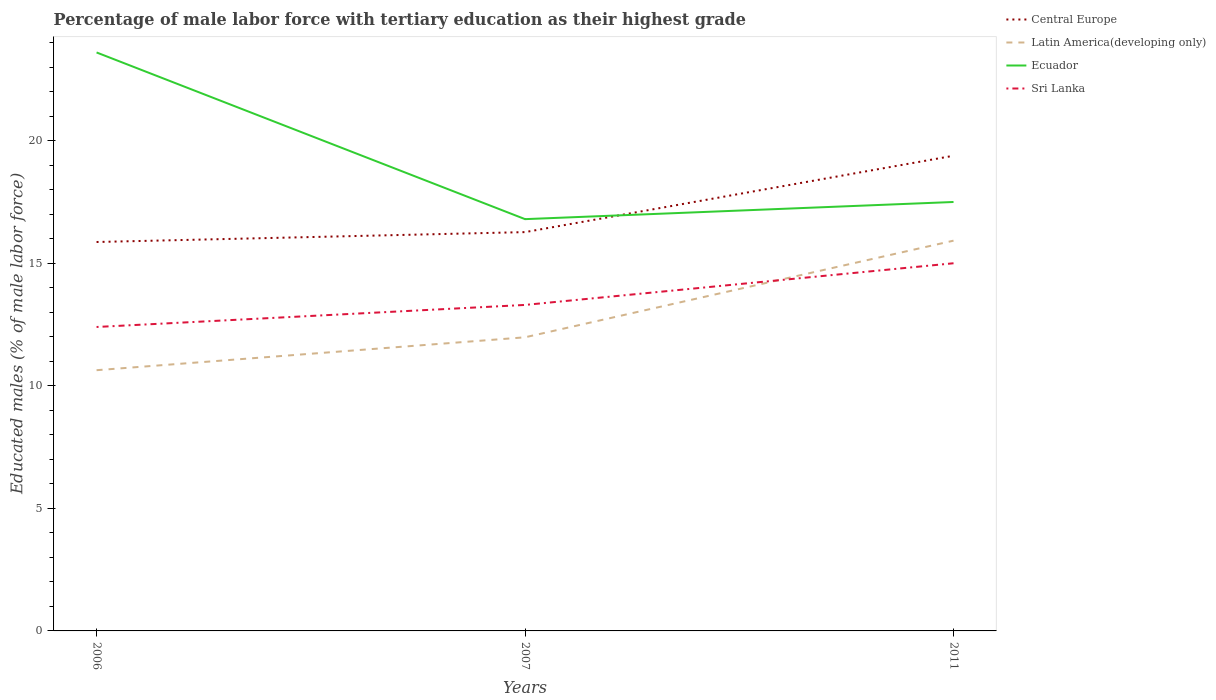Does the line corresponding to Ecuador intersect with the line corresponding to Central Europe?
Keep it short and to the point. Yes. Across all years, what is the maximum percentage of male labor force with tertiary education in Central Europe?
Give a very brief answer. 15.87. In which year was the percentage of male labor force with tertiary education in Latin America(developing only) maximum?
Provide a short and direct response. 2006. What is the total percentage of male labor force with tertiary education in Ecuador in the graph?
Offer a terse response. 6.8. What is the difference between the highest and the second highest percentage of male labor force with tertiary education in Sri Lanka?
Your answer should be compact. 2.6. Is the percentage of male labor force with tertiary education in Latin America(developing only) strictly greater than the percentage of male labor force with tertiary education in Central Europe over the years?
Make the answer very short. Yes. Does the graph contain grids?
Provide a short and direct response. No. Where does the legend appear in the graph?
Provide a short and direct response. Top right. How many legend labels are there?
Provide a short and direct response. 4. What is the title of the graph?
Keep it short and to the point. Percentage of male labor force with tertiary education as their highest grade. Does "Belarus" appear as one of the legend labels in the graph?
Your response must be concise. No. What is the label or title of the X-axis?
Keep it short and to the point. Years. What is the label or title of the Y-axis?
Offer a terse response. Educated males (% of male labor force). What is the Educated males (% of male labor force) of Central Europe in 2006?
Give a very brief answer. 15.87. What is the Educated males (% of male labor force) in Latin America(developing only) in 2006?
Your answer should be very brief. 10.64. What is the Educated males (% of male labor force) in Ecuador in 2006?
Your response must be concise. 23.6. What is the Educated males (% of male labor force) of Sri Lanka in 2006?
Provide a succinct answer. 12.4. What is the Educated males (% of male labor force) of Central Europe in 2007?
Your answer should be compact. 16.27. What is the Educated males (% of male labor force) in Latin America(developing only) in 2007?
Your response must be concise. 11.98. What is the Educated males (% of male labor force) of Ecuador in 2007?
Your answer should be very brief. 16.8. What is the Educated males (% of male labor force) in Sri Lanka in 2007?
Your answer should be compact. 13.3. What is the Educated males (% of male labor force) of Central Europe in 2011?
Your answer should be very brief. 19.39. What is the Educated males (% of male labor force) of Latin America(developing only) in 2011?
Provide a succinct answer. 15.92. Across all years, what is the maximum Educated males (% of male labor force) in Central Europe?
Make the answer very short. 19.39. Across all years, what is the maximum Educated males (% of male labor force) in Latin America(developing only)?
Make the answer very short. 15.92. Across all years, what is the maximum Educated males (% of male labor force) of Ecuador?
Ensure brevity in your answer.  23.6. Across all years, what is the minimum Educated males (% of male labor force) in Central Europe?
Provide a short and direct response. 15.87. Across all years, what is the minimum Educated males (% of male labor force) in Latin America(developing only)?
Your response must be concise. 10.64. Across all years, what is the minimum Educated males (% of male labor force) in Ecuador?
Your answer should be very brief. 16.8. Across all years, what is the minimum Educated males (% of male labor force) of Sri Lanka?
Provide a short and direct response. 12.4. What is the total Educated males (% of male labor force) of Central Europe in the graph?
Keep it short and to the point. 51.52. What is the total Educated males (% of male labor force) in Latin America(developing only) in the graph?
Provide a short and direct response. 38.54. What is the total Educated males (% of male labor force) of Ecuador in the graph?
Your response must be concise. 57.9. What is the total Educated males (% of male labor force) in Sri Lanka in the graph?
Your response must be concise. 40.7. What is the difference between the Educated males (% of male labor force) in Central Europe in 2006 and that in 2007?
Provide a succinct answer. -0.4. What is the difference between the Educated males (% of male labor force) of Latin America(developing only) in 2006 and that in 2007?
Give a very brief answer. -1.34. What is the difference between the Educated males (% of male labor force) in Sri Lanka in 2006 and that in 2007?
Give a very brief answer. -0.9. What is the difference between the Educated males (% of male labor force) in Central Europe in 2006 and that in 2011?
Offer a very short reply. -3.52. What is the difference between the Educated males (% of male labor force) of Latin America(developing only) in 2006 and that in 2011?
Ensure brevity in your answer.  -5.28. What is the difference between the Educated males (% of male labor force) in Central Europe in 2007 and that in 2011?
Your answer should be very brief. -3.12. What is the difference between the Educated males (% of male labor force) in Latin America(developing only) in 2007 and that in 2011?
Make the answer very short. -3.94. What is the difference between the Educated males (% of male labor force) of Ecuador in 2007 and that in 2011?
Ensure brevity in your answer.  -0.7. What is the difference between the Educated males (% of male labor force) of Sri Lanka in 2007 and that in 2011?
Provide a short and direct response. -1.7. What is the difference between the Educated males (% of male labor force) of Central Europe in 2006 and the Educated males (% of male labor force) of Latin America(developing only) in 2007?
Your answer should be compact. 3.89. What is the difference between the Educated males (% of male labor force) in Central Europe in 2006 and the Educated males (% of male labor force) in Ecuador in 2007?
Your answer should be very brief. -0.93. What is the difference between the Educated males (% of male labor force) of Central Europe in 2006 and the Educated males (% of male labor force) of Sri Lanka in 2007?
Provide a succinct answer. 2.57. What is the difference between the Educated males (% of male labor force) of Latin America(developing only) in 2006 and the Educated males (% of male labor force) of Ecuador in 2007?
Ensure brevity in your answer.  -6.16. What is the difference between the Educated males (% of male labor force) of Latin America(developing only) in 2006 and the Educated males (% of male labor force) of Sri Lanka in 2007?
Ensure brevity in your answer.  -2.66. What is the difference between the Educated males (% of male labor force) of Central Europe in 2006 and the Educated males (% of male labor force) of Latin America(developing only) in 2011?
Your answer should be compact. -0.05. What is the difference between the Educated males (% of male labor force) of Central Europe in 2006 and the Educated males (% of male labor force) of Ecuador in 2011?
Offer a terse response. -1.63. What is the difference between the Educated males (% of male labor force) in Central Europe in 2006 and the Educated males (% of male labor force) in Sri Lanka in 2011?
Your response must be concise. 0.87. What is the difference between the Educated males (% of male labor force) in Latin America(developing only) in 2006 and the Educated males (% of male labor force) in Ecuador in 2011?
Your answer should be compact. -6.86. What is the difference between the Educated males (% of male labor force) of Latin America(developing only) in 2006 and the Educated males (% of male labor force) of Sri Lanka in 2011?
Your answer should be very brief. -4.36. What is the difference between the Educated males (% of male labor force) of Central Europe in 2007 and the Educated males (% of male labor force) of Latin America(developing only) in 2011?
Offer a very short reply. 0.35. What is the difference between the Educated males (% of male labor force) in Central Europe in 2007 and the Educated males (% of male labor force) in Ecuador in 2011?
Offer a very short reply. -1.23. What is the difference between the Educated males (% of male labor force) of Central Europe in 2007 and the Educated males (% of male labor force) of Sri Lanka in 2011?
Ensure brevity in your answer.  1.27. What is the difference between the Educated males (% of male labor force) in Latin America(developing only) in 2007 and the Educated males (% of male labor force) in Ecuador in 2011?
Provide a short and direct response. -5.52. What is the difference between the Educated males (% of male labor force) in Latin America(developing only) in 2007 and the Educated males (% of male labor force) in Sri Lanka in 2011?
Your answer should be very brief. -3.02. What is the difference between the Educated males (% of male labor force) of Ecuador in 2007 and the Educated males (% of male labor force) of Sri Lanka in 2011?
Your answer should be very brief. 1.8. What is the average Educated males (% of male labor force) of Central Europe per year?
Your response must be concise. 17.17. What is the average Educated males (% of male labor force) in Latin America(developing only) per year?
Your answer should be very brief. 12.85. What is the average Educated males (% of male labor force) in Ecuador per year?
Provide a short and direct response. 19.3. What is the average Educated males (% of male labor force) in Sri Lanka per year?
Your answer should be compact. 13.57. In the year 2006, what is the difference between the Educated males (% of male labor force) in Central Europe and Educated males (% of male labor force) in Latin America(developing only)?
Your answer should be very brief. 5.23. In the year 2006, what is the difference between the Educated males (% of male labor force) of Central Europe and Educated males (% of male labor force) of Ecuador?
Your response must be concise. -7.73. In the year 2006, what is the difference between the Educated males (% of male labor force) of Central Europe and Educated males (% of male labor force) of Sri Lanka?
Keep it short and to the point. 3.47. In the year 2006, what is the difference between the Educated males (% of male labor force) in Latin America(developing only) and Educated males (% of male labor force) in Ecuador?
Your response must be concise. -12.96. In the year 2006, what is the difference between the Educated males (% of male labor force) of Latin America(developing only) and Educated males (% of male labor force) of Sri Lanka?
Provide a short and direct response. -1.76. In the year 2006, what is the difference between the Educated males (% of male labor force) in Ecuador and Educated males (% of male labor force) in Sri Lanka?
Your answer should be compact. 11.2. In the year 2007, what is the difference between the Educated males (% of male labor force) in Central Europe and Educated males (% of male labor force) in Latin America(developing only)?
Provide a short and direct response. 4.29. In the year 2007, what is the difference between the Educated males (% of male labor force) in Central Europe and Educated males (% of male labor force) in Ecuador?
Offer a terse response. -0.53. In the year 2007, what is the difference between the Educated males (% of male labor force) in Central Europe and Educated males (% of male labor force) in Sri Lanka?
Provide a short and direct response. 2.97. In the year 2007, what is the difference between the Educated males (% of male labor force) of Latin America(developing only) and Educated males (% of male labor force) of Ecuador?
Provide a succinct answer. -4.82. In the year 2007, what is the difference between the Educated males (% of male labor force) in Latin America(developing only) and Educated males (% of male labor force) in Sri Lanka?
Provide a succinct answer. -1.32. In the year 2011, what is the difference between the Educated males (% of male labor force) in Central Europe and Educated males (% of male labor force) in Latin America(developing only)?
Offer a terse response. 3.46. In the year 2011, what is the difference between the Educated males (% of male labor force) of Central Europe and Educated males (% of male labor force) of Ecuador?
Offer a very short reply. 1.89. In the year 2011, what is the difference between the Educated males (% of male labor force) in Central Europe and Educated males (% of male labor force) in Sri Lanka?
Offer a very short reply. 4.39. In the year 2011, what is the difference between the Educated males (% of male labor force) of Latin America(developing only) and Educated males (% of male labor force) of Ecuador?
Provide a short and direct response. -1.58. In the year 2011, what is the difference between the Educated males (% of male labor force) in Latin America(developing only) and Educated males (% of male labor force) in Sri Lanka?
Ensure brevity in your answer.  0.92. In the year 2011, what is the difference between the Educated males (% of male labor force) of Ecuador and Educated males (% of male labor force) of Sri Lanka?
Keep it short and to the point. 2.5. What is the ratio of the Educated males (% of male labor force) of Central Europe in 2006 to that in 2007?
Ensure brevity in your answer.  0.98. What is the ratio of the Educated males (% of male labor force) of Latin America(developing only) in 2006 to that in 2007?
Give a very brief answer. 0.89. What is the ratio of the Educated males (% of male labor force) of Ecuador in 2006 to that in 2007?
Ensure brevity in your answer.  1.4. What is the ratio of the Educated males (% of male labor force) of Sri Lanka in 2006 to that in 2007?
Offer a terse response. 0.93. What is the ratio of the Educated males (% of male labor force) of Central Europe in 2006 to that in 2011?
Provide a succinct answer. 0.82. What is the ratio of the Educated males (% of male labor force) in Latin America(developing only) in 2006 to that in 2011?
Your response must be concise. 0.67. What is the ratio of the Educated males (% of male labor force) of Ecuador in 2006 to that in 2011?
Make the answer very short. 1.35. What is the ratio of the Educated males (% of male labor force) in Sri Lanka in 2006 to that in 2011?
Your answer should be very brief. 0.83. What is the ratio of the Educated males (% of male labor force) of Central Europe in 2007 to that in 2011?
Make the answer very short. 0.84. What is the ratio of the Educated males (% of male labor force) in Latin America(developing only) in 2007 to that in 2011?
Offer a very short reply. 0.75. What is the ratio of the Educated males (% of male labor force) of Sri Lanka in 2007 to that in 2011?
Ensure brevity in your answer.  0.89. What is the difference between the highest and the second highest Educated males (% of male labor force) in Central Europe?
Keep it short and to the point. 3.12. What is the difference between the highest and the second highest Educated males (% of male labor force) in Latin America(developing only)?
Offer a terse response. 3.94. What is the difference between the highest and the lowest Educated males (% of male labor force) in Central Europe?
Provide a succinct answer. 3.52. What is the difference between the highest and the lowest Educated males (% of male labor force) of Latin America(developing only)?
Ensure brevity in your answer.  5.28. What is the difference between the highest and the lowest Educated males (% of male labor force) of Sri Lanka?
Give a very brief answer. 2.6. 